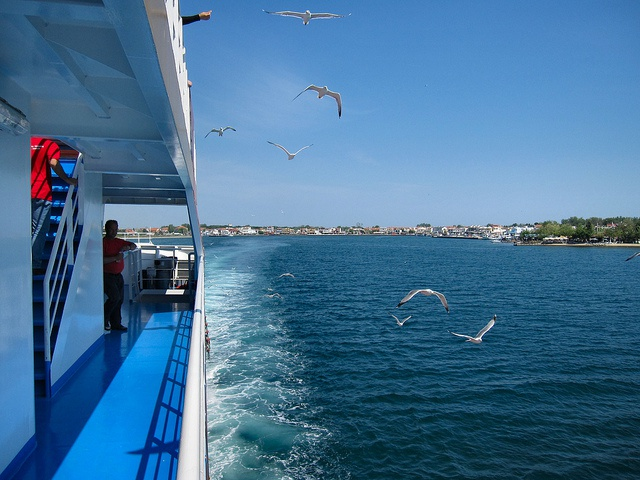Describe the objects in this image and their specific colors. I can see boat in blue, navy, and gray tones, people in blue, black, red, navy, and brown tones, people in blue, black, gray, and maroon tones, bird in blue, darkgray, gray, and lightblue tones, and bird in blue, gray, darkgray, and lightgray tones in this image. 